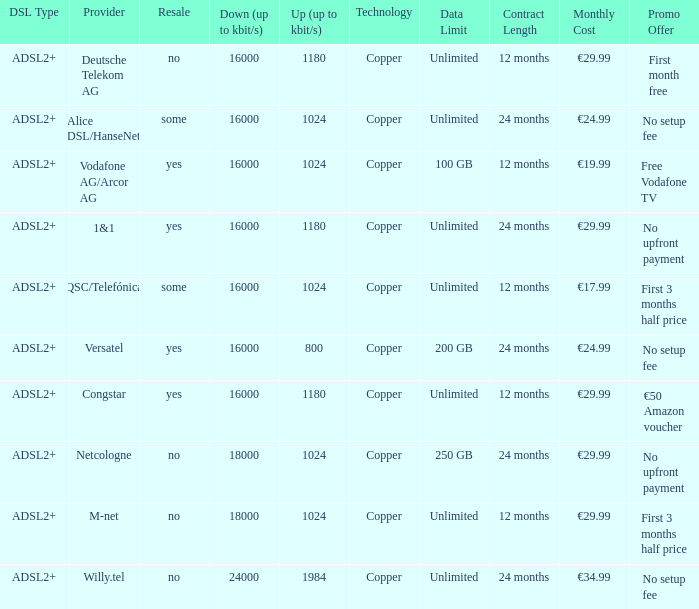What is download bandwith where the provider is deutsche telekom ag? 16000.0. 